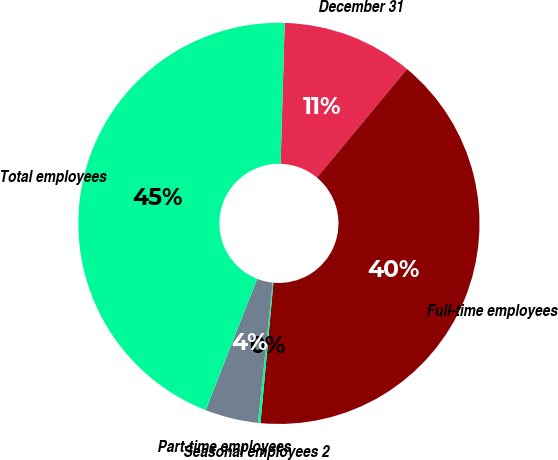<chart> <loc_0><loc_0><loc_500><loc_500><pie_chart><fcel>December 31<fcel>Full-time employees<fcel>Seasonal employees 2<fcel>Part-time employees<fcel>Total employees<nl><fcel>10.57%<fcel>40.44%<fcel>0.2%<fcel>4.28%<fcel>44.51%<nl></chart> 